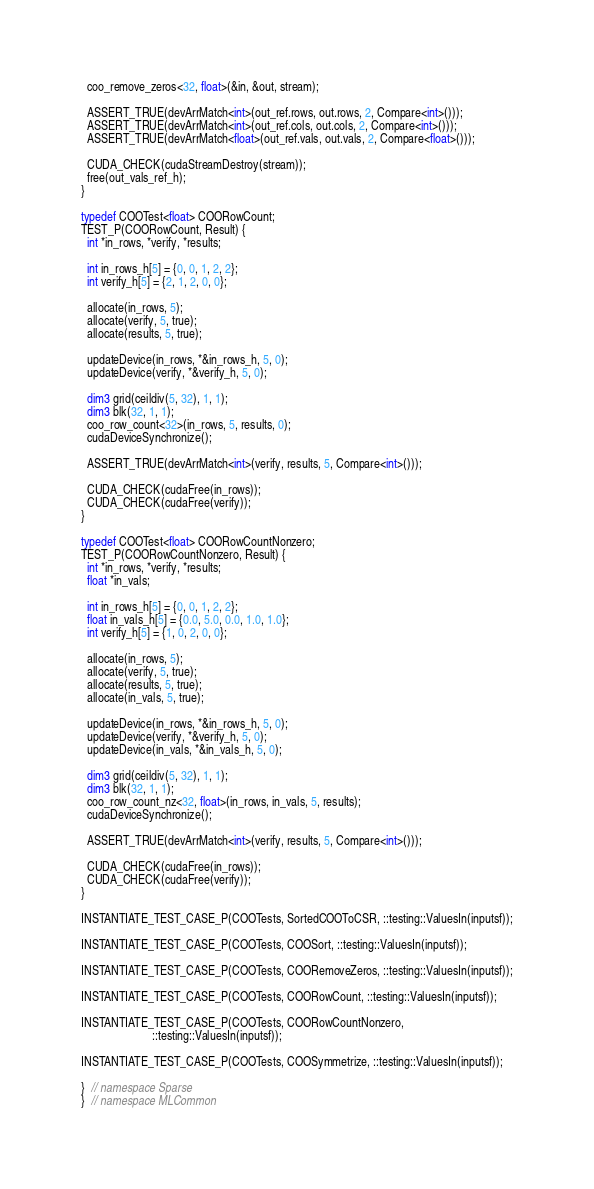Convert code to text. <code><loc_0><loc_0><loc_500><loc_500><_Cuda_>
  coo_remove_zeros<32, float>(&in, &out, stream);

  ASSERT_TRUE(devArrMatch<int>(out_ref.rows, out.rows, 2, Compare<int>()));
  ASSERT_TRUE(devArrMatch<int>(out_ref.cols, out.cols, 2, Compare<int>()));
  ASSERT_TRUE(devArrMatch<float>(out_ref.vals, out.vals, 2, Compare<float>()));

  CUDA_CHECK(cudaStreamDestroy(stream));
  free(out_vals_ref_h);
}

typedef COOTest<float> COORowCount;
TEST_P(COORowCount, Result) {
  int *in_rows, *verify, *results;

  int in_rows_h[5] = {0, 0, 1, 2, 2};
  int verify_h[5] = {2, 1, 2, 0, 0};

  allocate(in_rows, 5);
  allocate(verify, 5, true);
  allocate(results, 5, true);

  updateDevice(in_rows, *&in_rows_h, 5, 0);
  updateDevice(verify, *&verify_h, 5, 0);

  dim3 grid(ceildiv(5, 32), 1, 1);
  dim3 blk(32, 1, 1);
  coo_row_count<32>(in_rows, 5, results, 0);
  cudaDeviceSynchronize();

  ASSERT_TRUE(devArrMatch<int>(verify, results, 5, Compare<int>()));

  CUDA_CHECK(cudaFree(in_rows));
  CUDA_CHECK(cudaFree(verify));
}

typedef COOTest<float> COORowCountNonzero;
TEST_P(COORowCountNonzero, Result) {
  int *in_rows, *verify, *results;
  float *in_vals;

  int in_rows_h[5] = {0, 0, 1, 2, 2};
  float in_vals_h[5] = {0.0, 5.0, 0.0, 1.0, 1.0};
  int verify_h[5] = {1, 0, 2, 0, 0};

  allocate(in_rows, 5);
  allocate(verify, 5, true);
  allocate(results, 5, true);
  allocate(in_vals, 5, true);

  updateDevice(in_rows, *&in_rows_h, 5, 0);
  updateDevice(verify, *&verify_h, 5, 0);
  updateDevice(in_vals, *&in_vals_h, 5, 0);

  dim3 grid(ceildiv(5, 32), 1, 1);
  dim3 blk(32, 1, 1);
  coo_row_count_nz<32, float>(in_rows, in_vals, 5, results);
  cudaDeviceSynchronize();

  ASSERT_TRUE(devArrMatch<int>(verify, results, 5, Compare<int>()));

  CUDA_CHECK(cudaFree(in_rows));
  CUDA_CHECK(cudaFree(verify));
}

INSTANTIATE_TEST_CASE_P(COOTests, SortedCOOToCSR, ::testing::ValuesIn(inputsf));

INSTANTIATE_TEST_CASE_P(COOTests, COOSort, ::testing::ValuesIn(inputsf));

INSTANTIATE_TEST_CASE_P(COOTests, COORemoveZeros, ::testing::ValuesIn(inputsf));

INSTANTIATE_TEST_CASE_P(COOTests, COORowCount, ::testing::ValuesIn(inputsf));

INSTANTIATE_TEST_CASE_P(COOTests, COORowCountNonzero,
                        ::testing::ValuesIn(inputsf));

INSTANTIATE_TEST_CASE_P(COOTests, COOSymmetrize, ::testing::ValuesIn(inputsf));

}  // namespace Sparse
}  // namespace MLCommon
</code> 